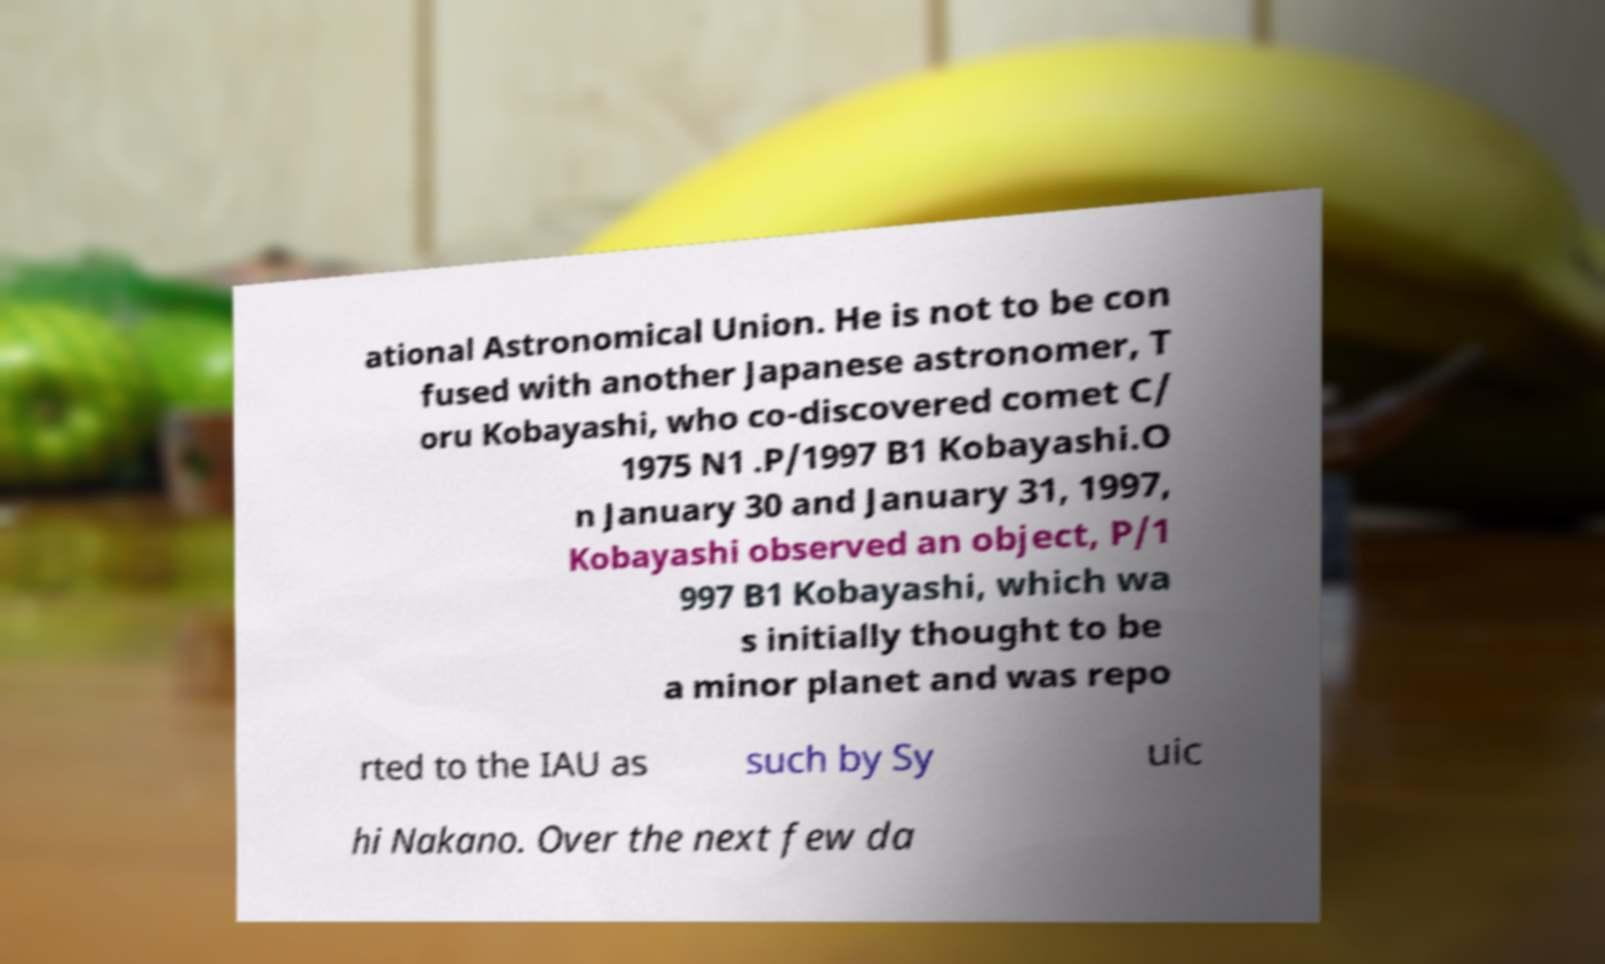Could you assist in decoding the text presented in this image and type it out clearly? ational Astronomical Union. He is not to be con fused with another Japanese astronomer, T oru Kobayashi, who co-discovered comet C/ 1975 N1 .P/1997 B1 Kobayashi.O n January 30 and January 31, 1997, Kobayashi observed an object, P/1 997 B1 Kobayashi, which wa s initially thought to be a minor planet and was repo rted to the IAU as such by Sy uic hi Nakano. Over the next few da 